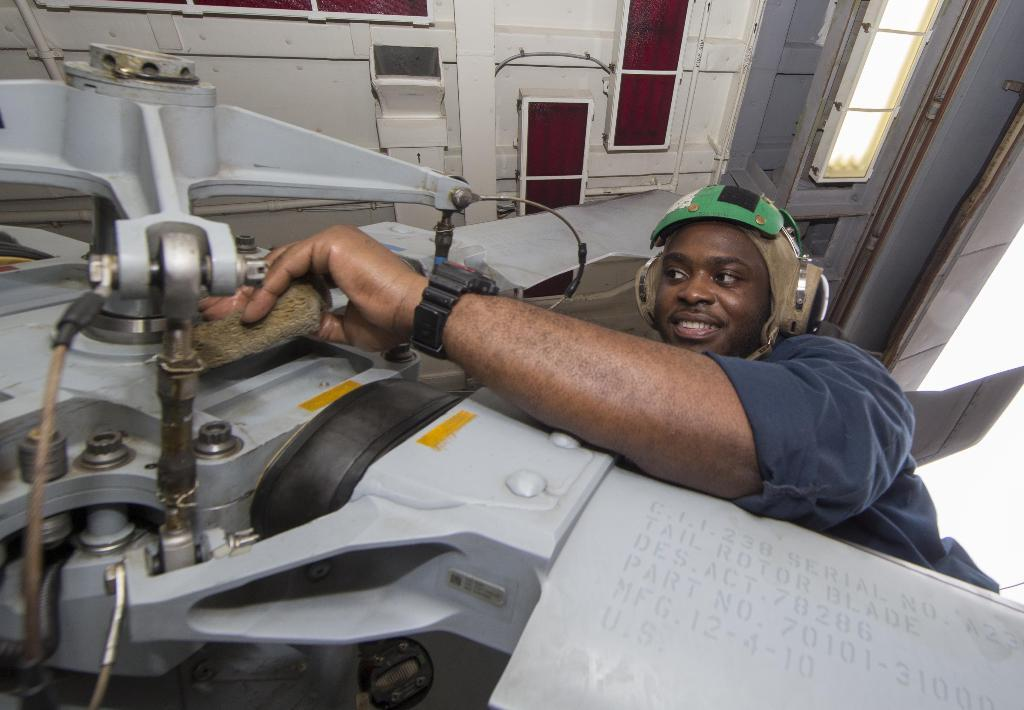What is the person in the image doing? The person is standing at the machinery. What can be seen in the background of the image? There are lights and a roof visible in the background. How many chairs are present at the party in the image? There is no party or chairs present in the image; it features a person standing at machinery with lights and a roof in the background. 